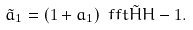Convert formula to latex. <formula><loc_0><loc_0><loc_500><loc_500>\tilde { a } _ { 1 } = ( 1 + a _ { 1 } ) \ f f t { \tilde { H } } H - 1 .</formula> 